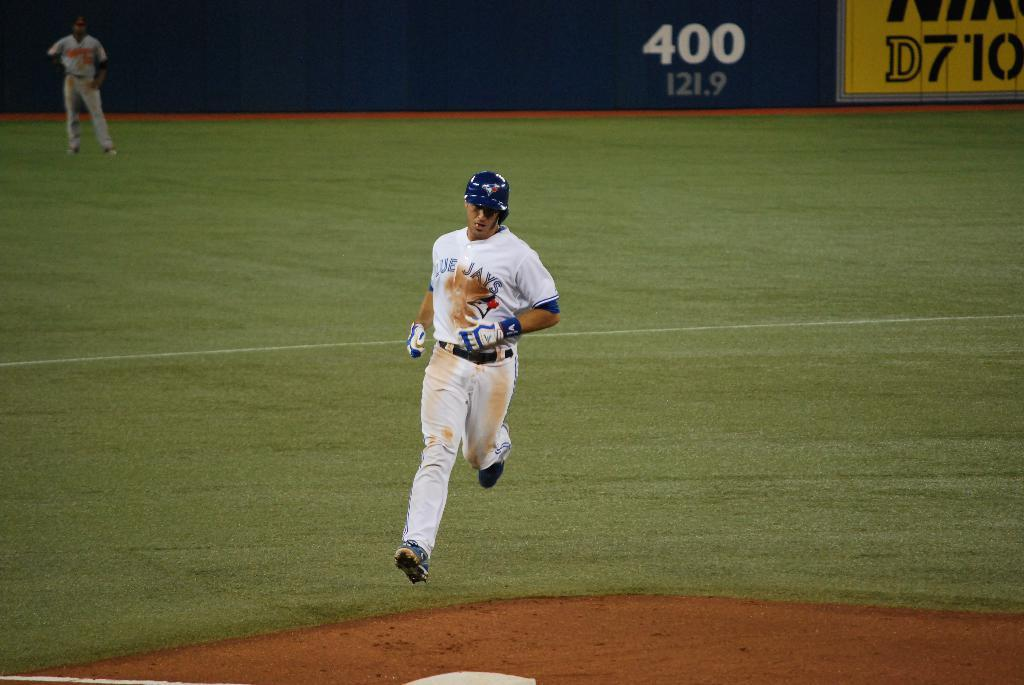<image>
Offer a succinct explanation of the picture presented. A player for the Blue Jays is running the bases. 